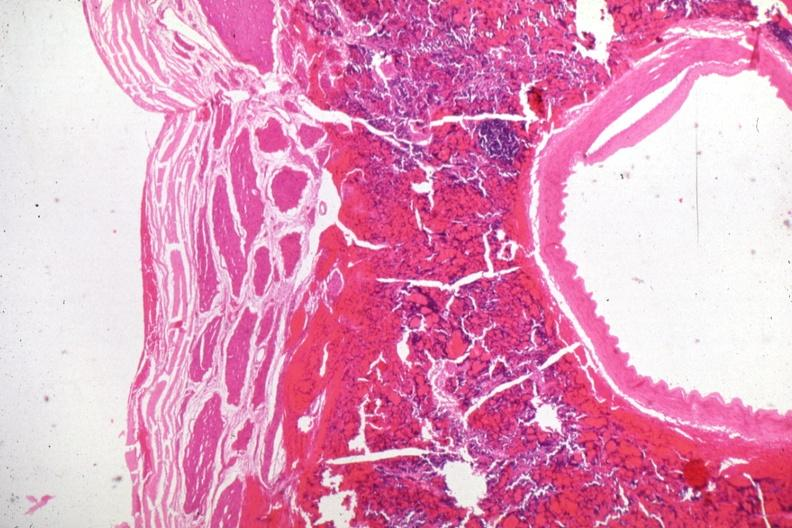where is this part in the figure?
Answer the question using a single word or phrase. Endocrine system 